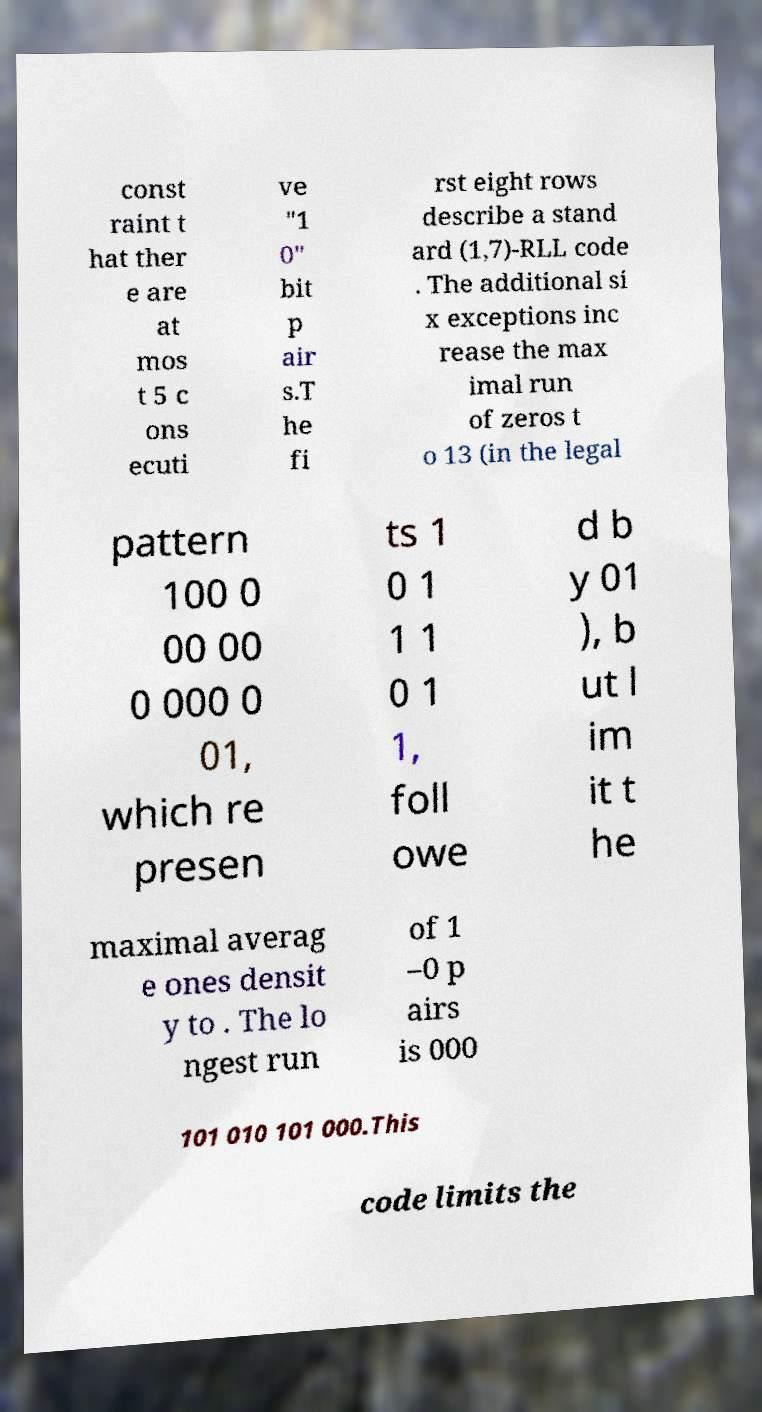Could you extract and type out the text from this image? const raint t hat ther e are at mos t 5 c ons ecuti ve "1 0" bit p air s.T he fi rst eight rows describe a stand ard (1,7)-RLL code . The additional si x exceptions inc rease the max imal run of zeros t o 13 (in the legal pattern 100 0 00 00 0 000 0 01, which re presen ts 1 0 1 1 1 0 1 1, foll owe d b y 01 ), b ut l im it t he maximal averag e ones densit y to . The lo ngest run of 1 –0 p airs is 000 101 010 101 000.This code limits the 